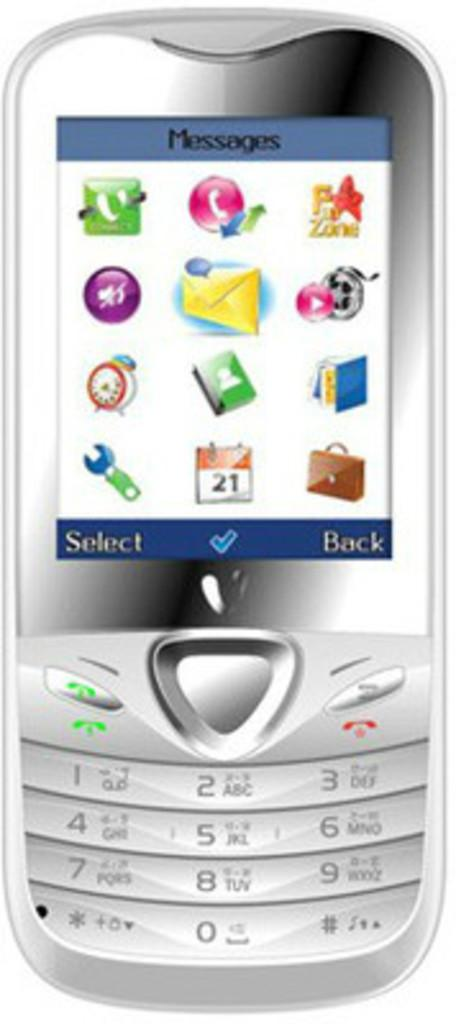<image>
Present a compact description of the photo's key features. A silver cell phone showing messages and icons on the screen.] 